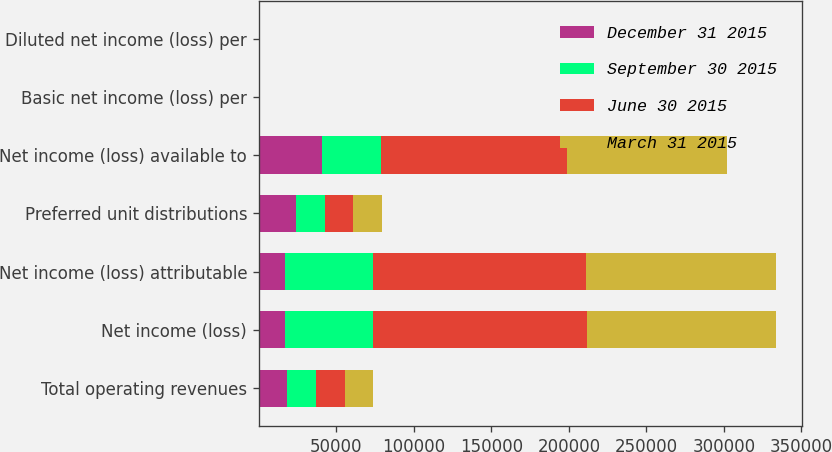<chart> <loc_0><loc_0><loc_500><loc_500><stacked_bar_chart><ecel><fcel>Total operating revenues<fcel>Net income (loss)<fcel>Net income (loss) attributable<fcel>Preferred unit distributions<fcel>Net income (loss) available to<fcel>Basic net income (loss) per<fcel>Diluted net income (loss) per<nl><fcel>December 31 2015<fcel>18456<fcel>16785<fcel>16903<fcel>24056<fcel>40959<fcel>0.28<fcel>0.28<nl><fcel>September 30 2015<fcel>18456<fcel>56689<fcel>56572<fcel>18456<fcel>38116<fcel>0.28<fcel>0.27<nl><fcel>June 30 2015<fcel>18456<fcel>137997<fcel>137888<fcel>18456<fcel>119432<fcel>0.86<fcel>0.86<nl><fcel>March 31 2015<fcel>18456<fcel>122325<fcel>122209<fcel>18455<fcel>103754<fcel>0.75<fcel>0.75<nl></chart> 